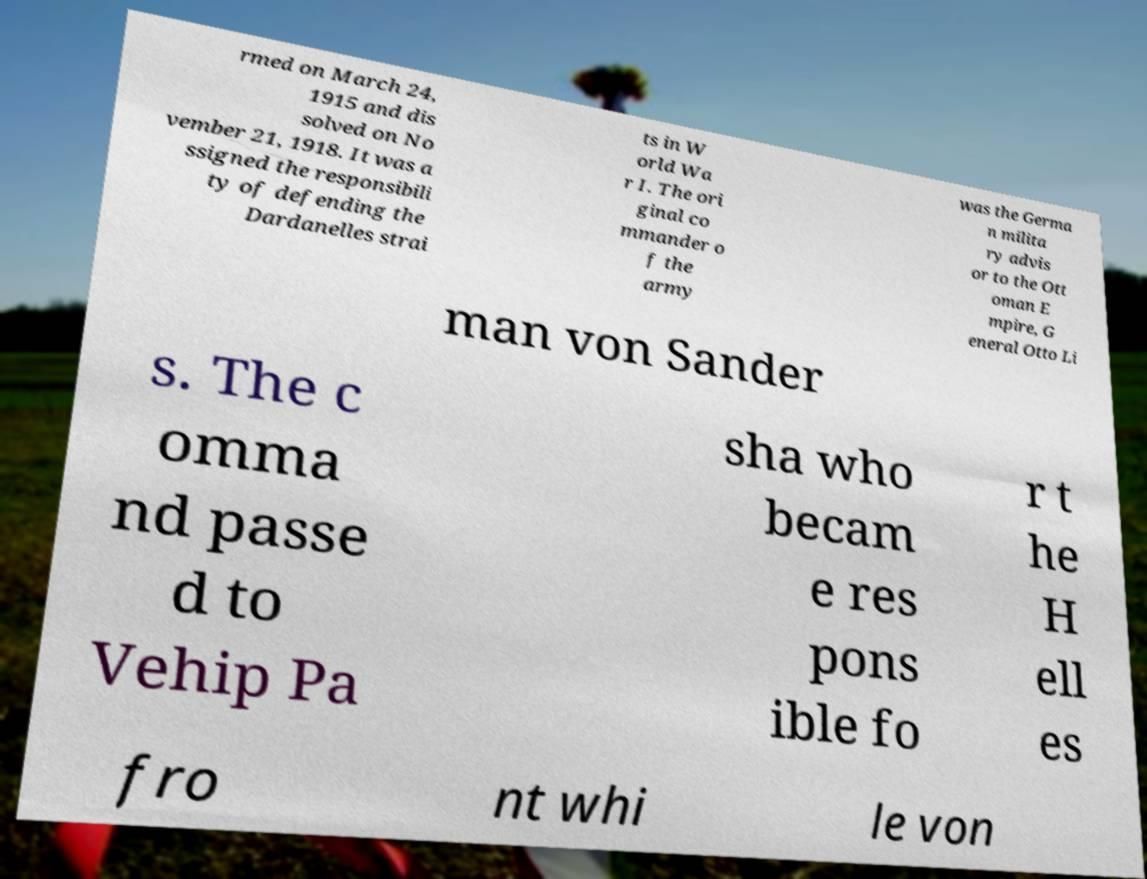I need the written content from this picture converted into text. Can you do that? rmed on March 24, 1915 and dis solved on No vember 21, 1918. It was a ssigned the responsibili ty of defending the Dardanelles strai ts in W orld Wa r I. The ori ginal co mmander o f the army was the Germa n milita ry advis or to the Ott oman E mpire, G eneral Otto Li man von Sander s. The c omma nd passe d to Vehip Pa sha who becam e res pons ible fo r t he H ell es fro nt whi le von 